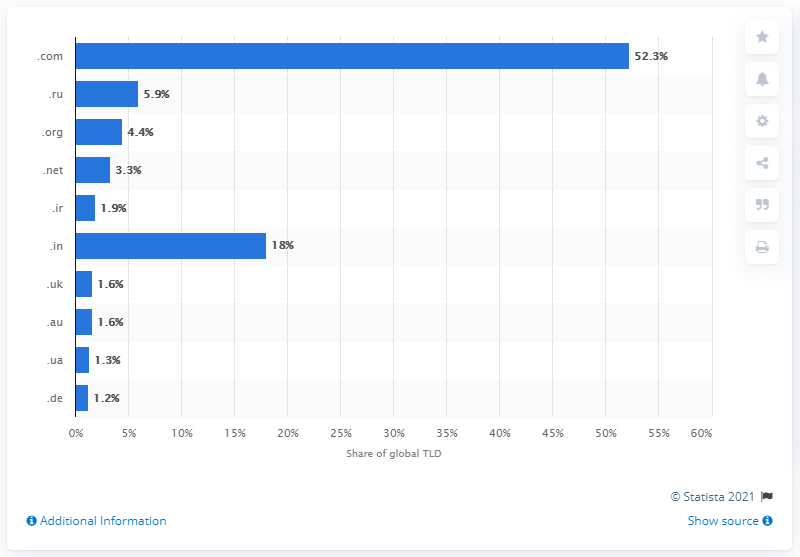List a handful of essential elements in this visual. As of April 2021, 52.3% of global websites used the ".com" top-level domain. 